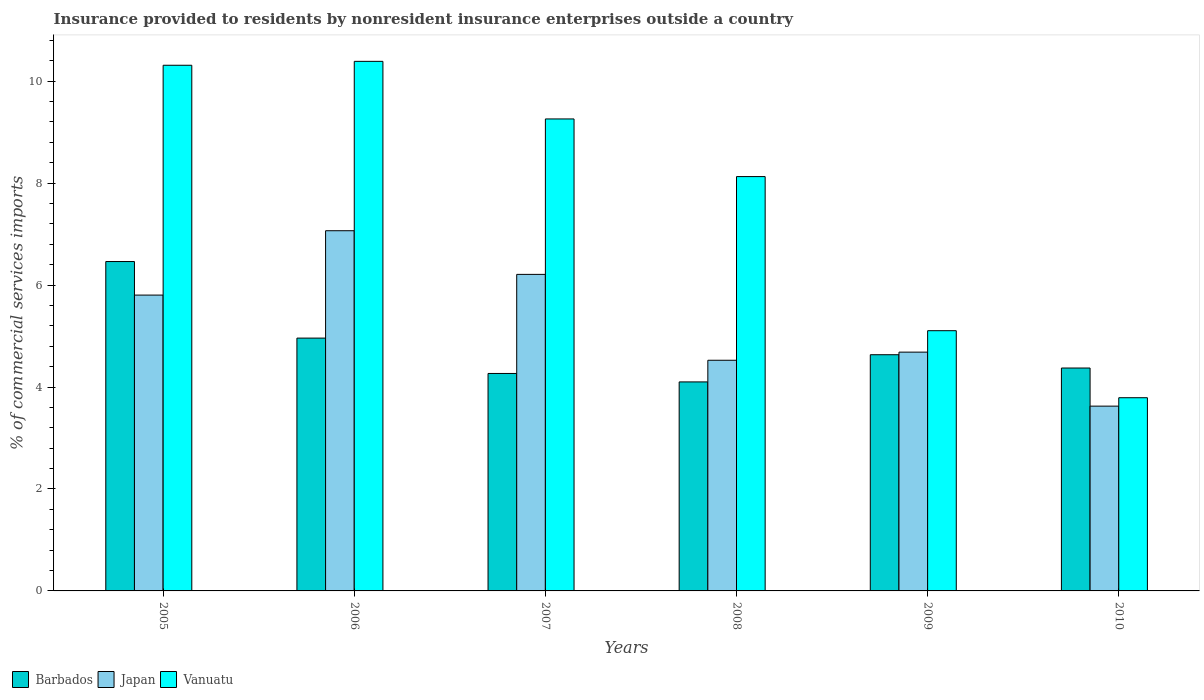How many different coloured bars are there?
Give a very brief answer. 3. How many groups of bars are there?
Offer a very short reply. 6. Are the number of bars per tick equal to the number of legend labels?
Your response must be concise. Yes. How many bars are there on the 5th tick from the left?
Your answer should be very brief. 3. How many bars are there on the 6th tick from the right?
Your answer should be very brief. 3. What is the label of the 5th group of bars from the left?
Offer a terse response. 2009. What is the Insurance provided to residents in Vanuatu in 2008?
Provide a succinct answer. 8.13. Across all years, what is the maximum Insurance provided to residents in Vanuatu?
Keep it short and to the point. 10.39. Across all years, what is the minimum Insurance provided to residents in Japan?
Your response must be concise. 3.63. In which year was the Insurance provided to residents in Japan minimum?
Your answer should be very brief. 2010. What is the total Insurance provided to residents in Vanuatu in the graph?
Offer a very short reply. 46.98. What is the difference between the Insurance provided to residents in Barbados in 2006 and that in 2008?
Ensure brevity in your answer.  0.86. What is the difference between the Insurance provided to residents in Vanuatu in 2008 and the Insurance provided to residents in Barbados in 2006?
Provide a short and direct response. 3.17. What is the average Insurance provided to residents in Vanuatu per year?
Offer a very short reply. 7.83. In the year 2006, what is the difference between the Insurance provided to residents in Japan and Insurance provided to residents in Vanuatu?
Provide a short and direct response. -3.32. What is the ratio of the Insurance provided to residents in Vanuatu in 2007 to that in 2008?
Your answer should be very brief. 1.14. Is the Insurance provided to residents in Vanuatu in 2009 less than that in 2010?
Make the answer very short. No. Is the difference between the Insurance provided to residents in Japan in 2008 and 2010 greater than the difference between the Insurance provided to residents in Vanuatu in 2008 and 2010?
Give a very brief answer. No. What is the difference between the highest and the second highest Insurance provided to residents in Barbados?
Give a very brief answer. 1.5. What is the difference between the highest and the lowest Insurance provided to residents in Barbados?
Offer a terse response. 2.36. In how many years, is the Insurance provided to residents in Barbados greater than the average Insurance provided to residents in Barbados taken over all years?
Offer a very short reply. 2. What does the 1st bar from the left in 2010 represents?
Keep it short and to the point. Barbados. How many bars are there?
Your answer should be compact. 18. Are all the bars in the graph horizontal?
Offer a very short reply. No. What is the difference between two consecutive major ticks on the Y-axis?
Offer a very short reply. 2. Does the graph contain any zero values?
Your response must be concise. No. Does the graph contain grids?
Give a very brief answer. No. Where does the legend appear in the graph?
Your response must be concise. Bottom left. How are the legend labels stacked?
Provide a short and direct response. Horizontal. What is the title of the graph?
Give a very brief answer. Insurance provided to residents by nonresident insurance enterprises outside a country. Does "Qatar" appear as one of the legend labels in the graph?
Ensure brevity in your answer.  No. What is the label or title of the X-axis?
Provide a succinct answer. Years. What is the label or title of the Y-axis?
Your response must be concise. % of commercial services imports. What is the % of commercial services imports of Barbados in 2005?
Give a very brief answer. 6.46. What is the % of commercial services imports in Japan in 2005?
Your response must be concise. 5.8. What is the % of commercial services imports of Vanuatu in 2005?
Keep it short and to the point. 10.31. What is the % of commercial services imports in Barbados in 2006?
Offer a terse response. 4.96. What is the % of commercial services imports in Japan in 2006?
Give a very brief answer. 7.07. What is the % of commercial services imports of Vanuatu in 2006?
Ensure brevity in your answer.  10.39. What is the % of commercial services imports of Barbados in 2007?
Keep it short and to the point. 4.27. What is the % of commercial services imports of Japan in 2007?
Your answer should be compact. 6.21. What is the % of commercial services imports of Vanuatu in 2007?
Your response must be concise. 9.26. What is the % of commercial services imports of Barbados in 2008?
Offer a very short reply. 4.1. What is the % of commercial services imports in Japan in 2008?
Ensure brevity in your answer.  4.53. What is the % of commercial services imports in Vanuatu in 2008?
Your answer should be compact. 8.13. What is the % of commercial services imports in Barbados in 2009?
Your answer should be very brief. 4.63. What is the % of commercial services imports of Japan in 2009?
Keep it short and to the point. 4.68. What is the % of commercial services imports of Vanuatu in 2009?
Your answer should be very brief. 5.1. What is the % of commercial services imports of Barbados in 2010?
Give a very brief answer. 4.37. What is the % of commercial services imports in Japan in 2010?
Your response must be concise. 3.63. What is the % of commercial services imports in Vanuatu in 2010?
Keep it short and to the point. 3.79. Across all years, what is the maximum % of commercial services imports in Barbados?
Your answer should be compact. 6.46. Across all years, what is the maximum % of commercial services imports of Japan?
Make the answer very short. 7.07. Across all years, what is the maximum % of commercial services imports of Vanuatu?
Provide a short and direct response. 10.39. Across all years, what is the minimum % of commercial services imports of Barbados?
Ensure brevity in your answer.  4.1. Across all years, what is the minimum % of commercial services imports of Japan?
Your response must be concise. 3.63. Across all years, what is the minimum % of commercial services imports of Vanuatu?
Provide a succinct answer. 3.79. What is the total % of commercial services imports of Barbados in the graph?
Your answer should be compact. 28.79. What is the total % of commercial services imports of Japan in the graph?
Make the answer very short. 31.91. What is the total % of commercial services imports in Vanuatu in the graph?
Offer a very short reply. 46.98. What is the difference between the % of commercial services imports of Barbados in 2005 and that in 2006?
Your answer should be compact. 1.5. What is the difference between the % of commercial services imports of Japan in 2005 and that in 2006?
Your answer should be very brief. -1.26. What is the difference between the % of commercial services imports of Vanuatu in 2005 and that in 2006?
Offer a terse response. -0.08. What is the difference between the % of commercial services imports in Barbados in 2005 and that in 2007?
Your answer should be very brief. 2.2. What is the difference between the % of commercial services imports in Japan in 2005 and that in 2007?
Offer a terse response. -0.41. What is the difference between the % of commercial services imports in Vanuatu in 2005 and that in 2007?
Your response must be concise. 1.05. What is the difference between the % of commercial services imports of Barbados in 2005 and that in 2008?
Your response must be concise. 2.36. What is the difference between the % of commercial services imports of Japan in 2005 and that in 2008?
Ensure brevity in your answer.  1.28. What is the difference between the % of commercial services imports in Vanuatu in 2005 and that in 2008?
Keep it short and to the point. 2.18. What is the difference between the % of commercial services imports in Barbados in 2005 and that in 2009?
Your answer should be compact. 1.83. What is the difference between the % of commercial services imports of Japan in 2005 and that in 2009?
Offer a terse response. 1.12. What is the difference between the % of commercial services imports of Vanuatu in 2005 and that in 2009?
Your answer should be compact. 5.21. What is the difference between the % of commercial services imports of Barbados in 2005 and that in 2010?
Give a very brief answer. 2.09. What is the difference between the % of commercial services imports of Japan in 2005 and that in 2010?
Offer a terse response. 2.18. What is the difference between the % of commercial services imports in Vanuatu in 2005 and that in 2010?
Provide a succinct answer. 6.52. What is the difference between the % of commercial services imports of Barbados in 2006 and that in 2007?
Your answer should be very brief. 0.69. What is the difference between the % of commercial services imports in Japan in 2006 and that in 2007?
Offer a very short reply. 0.86. What is the difference between the % of commercial services imports of Vanuatu in 2006 and that in 2007?
Provide a short and direct response. 1.13. What is the difference between the % of commercial services imports in Barbados in 2006 and that in 2008?
Keep it short and to the point. 0.86. What is the difference between the % of commercial services imports of Japan in 2006 and that in 2008?
Provide a succinct answer. 2.54. What is the difference between the % of commercial services imports in Vanuatu in 2006 and that in 2008?
Make the answer very short. 2.26. What is the difference between the % of commercial services imports of Barbados in 2006 and that in 2009?
Provide a short and direct response. 0.33. What is the difference between the % of commercial services imports of Japan in 2006 and that in 2009?
Your response must be concise. 2.38. What is the difference between the % of commercial services imports in Vanuatu in 2006 and that in 2009?
Your answer should be compact. 5.28. What is the difference between the % of commercial services imports of Barbados in 2006 and that in 2010?
Ensure brevity in your answer.  0.59. What is the difference between the % of commercial services imports of Japan in 2006 and that in 2010?
Your answer should be compact. 3.44. What is the difference between the % of commercial services imports in Vanuatu in 2006 and that in 2010?
Ensure brevity in your answer.  6.6. What is the difference between the % of commercial services imports of Barbados in 2007 and that in 2008?
Provide a short and direct response. 0.17. What is the difference between the % of commercial services imports of Japan in 2007 and that in 2008?
Provide a succinct answer. 1.68. What is the difference between the % of commercial services imports of Vanuatu in 2007 and that in 2008?
Your answer should be very brief. 1.13. What is the difference between the % of commercial services imports of Barbados in 2007 and that in 2009?
Provide a short and direct response. -0.37. What is the difference between the % of commercial services imports of Japan in 2007 and that in 2009?
Your response must be concise. 1.53. What is the difference between the % of commercial services imports in Vanuatu in 2007 and that in 2009?
Your response must be concise. 4.15. What is the difference between the % of commercial services imports in Barbados in 2007 and that in 2010?
Your answer should be compact. -0.11. What is the difference between the % of commercial services imports of Japan in 2007 and that in 2010?
Keep it short and to the point. 2.58. What is the difference between the % of commercial services imports of Vanuatu in 2007 and that in 2010?
Give a very brief answer. 5.47. What is the difference between the % of commercial services imports in Barbados in 2008 and that in 2009?
Your response must be concise. -0.53. What is the difference between the % of commercial services imports of Japan in 2008 and that in 2009?
Ensure brevity in your answer.  -0.16. What is the difference between the % of commercial services imports in Vanuatu in 2008 and that in 2009?
Your answer should be compact. 3.02. What is the difference between the % of commercial services imports of Barbados in 2008 and that in 2010?
Provide a short and direct response. -0.27. What is the difference between the % of commercial services imports in Japan in 2008 and that in 2010?
Make the answer very short. 0.9. What is the difference between the % of commercial services imports in Vanuatu in 2008 and that in 2010?
Offer a terse response. 4.34. What is the difference between the % of commercial services imports of Barbados in 2009 and that in 2010?
Provide a succinct answer. 0.26. What is the difference between the % of commercial services imports in Japan in 2009 and that in 2010?
Provide a short and direct response. 1.06. What is the difference between the % of commercial services imports of Vanuatu in 2009 and that in 2010?
Your answer should be very brief. 1.31. What is the difference between the % of commercial services imports of Barbados in 2005 and the % of commercial services imports of Japan in 2006?
Provide a succinct answer. -0.6. What is the difference between the % of commercial services imports in Barbados in 2005 and the % of commercial services imports in Vanuatu in 2006?
Make the answer very short. -3.93. What is the difference between the % of commercial services imports of Japan in 2005 and the % of commercial services imports of Vanuatu in 2006?
Offer a very short reply. -4.59. What is the difference between the % of commercial services imports in Barbados in 2005 and the % of commercial services imports in Japan in 2007?
Your answer should be very brief. 0.25. What is the difference between the % of commercial services imports in Barbados in 2005 and the % of commercial services imports in Vanuatu in 2007?
Give a very brief answer. -2.8. What is the difference between the % of commercial services imports in Japan in 2005 and the % of commercial services imports in Vanuatu in 2007?
Offer a very short reply. -3.46. What is the difference between the % of commercial services imports of Barbados in 2005 and the % of commercial services imports of Japan in 2008?
Your answer should be compact. 1.94. What is the difference between the % of commercial services imports of Barbados in 2005 and the % of commercial services imports of Vanuatu in 2008?
Your answer should be compact. -1.67. What is the difference between the % of commercial services imports of Japan in 2005 and the % of commercial services imports of Vanuatu in 2008?
Offer a very short reply. -2.32. What is the difference between the % of commercial services imports of Barbados in 2005 and the % of commercial services imports of Japan in 2009?
Provide a short and direct response. 1.78. What is the difference between the % of commercial services imports in Barbados in 2005 and the % of commercial services imports in Vanuatu in 2009?
Keep it short and to the point. 1.36. What is the difference between the % of commercial services imports of Japan in 2005 and the % of commercial services imports of Vanuatu in 2009?
Your answer should be compact. 0.7. What is the difference between the % of commercial services imports of Barbados in 2005 and the % of commercial services imports of Japan in 2010?
Ensure brevity in your answer.  2.84. What is the difference between the % of commercial services imports of Barbados in 2005 and the % of commercial services imports of Vanuatu in 2010?
Offer a very short reply. 2.67. What is the difference between the % of commercial services imports of Japan in 2005 and the % of commercial services imports of Vanuatu in 2010?
Provide a short and direct response. 2.01. What is the difference between the % of commercial services imports of Barbados in 2006 and the % of commercial services imports of Japan in 2007?
Provide a succinct answer. -1.25. What is the difference between the % of commercial services imports of Barbados in 2006 and the % of commercial services imports of Vanuatu in 2007?
Give a very brief answer. -4.3. What is the difference between the % of commercial services imports in Japan in 2006 and the % of commercial services imports in Vanuatu in 2007?
Give a very brief answer. -2.19. What is the difference between the % of commercial services imports in Barbados in 2006 and the % of commercial services imports in Japan in 2008?
Ensure brevity in your answer.  0.43. What is the difference between the % of commercial services imports in Barbados in 2006 and the % of commercial services imports in Vanuatu in 2008?
Ensure brevity in your answer.  -3.17. What is the difference between the % of commercial services imports of Japan in 2006 and the % of commercial services imports of Vanuatu in 2008?
Keep it short and to the point. -1.06. What is the difference between the % of commercial services imports in Barbados in 2006 and the % of commercial services imports in Japan in 2009?
Offer a terse response. 0.28. What is the difference between the % of commercial services imports in Barbados in 2006 and the % of commercial services imports in Vanuatu in 2009?
Offer a very short reply. -0.15. What is the difference between the % of commercial services imports of Japan in 2006 and the % of commercial services imports of Vanuatu in 2009?
Offer a terse response. 1.96. What is the difference between the % of commercial services imports in Barbados in 2006 and the % of commercial services imports in Japan in 2010?
Make the answer very short. 1.33. What is the difference between the % of commercial services imports of Barbados in 2006 and the % of commercial services imports of Vanuatu in 2010?
Your answer should be very brief. 1.17. What is the difference between the % of commercial services imports of Japan in 2006 and the % of commercial services imports of Vanuatu in 2010?
Your answer should be very brief. 3.28. What is the difference between the % of commercial services imports of Barbados in 2007 and the % of commercial services imports of Japan in 2008?
Keep it short and to the point. -0.26. What is the difference between the % of commercial services imports in Barbados in 2007 and the % of commercial services imports in Vanuatu in 2008?
Your answer should be very brief. -3.86. What is the difference between the % of commercial services imports of Japan in 2007 and the % of commercial services imports of Vanuatu in 2008?
Provide a succinct answer. -1.92. What is the difference between the % of commercial services imports of Barbados in 2007 and the % of commercial services imports of Japan in 2009?
Your answer should be very brief. -0.42. What is the difference between the % of commercial services imports in Barbados in 2007 and the % of commercial services imports in Vanuatu in 2009?
Provide a succinct answer. -0.84. What is the difference between the % of commercial services imports of Japan in 2007 and the % of commercial services imports of Vanuatu in 2009?
Keep it short and to the point. 1.1. What is the difference between the % of commercial services imports of Barbados in 2007 and the % of commercial services imports of Japan in 2010?
Provide a succinct answer. 0.64. What is the difference between the % of commercial services imports in Barbados in 2007 and the % of commercial services imports in Vanuatu in 2010?
Ensure brevity in your answer.  0.48. What is the difference between the % of commercial services imports in Japan in 2007 and the % of commercial services imports in Vanuatu in 2010?
Offer a very short reply. 2.42. What is the difference between the % of commercial services imports in Barbados in 2008 and the % of commercial services imports in Japan in 2009?
Your answer should be compact. -0.58. What is the difference between the % of commercial services imports of Barbados in 2008 and the % of commercial services imports of Vanuatu in 2009?
Make the answer very short. -1. What is the difference between the % of commercial services imports of Japan in 2008 and the % of commercial services imports of Vanuatu in 2009?
Offer a very short reply. -0.58. What is the difference between the % of commercial services imports in Barbados in 2008 and the % of commercial services imports in Japan in 2010?
Offer a terse response. 0.48. What is the difference between the % of commercial services imports in Barbados in 2008 and the % of commercial services imports in Vanuatu in 2010?
Offer a terse response. 0.31. What is the difference between the % of commercial services imports in Japan in 2008 and the % of commercial services imports in Vanuatu in 2010?
Your answer should be compact. 0.73. What is the difference between the % of commercial services imports in Barbados in 2009 and the % of commercial services imports in Japan in 2010?
Offer a very short reply. 1.01. What is the difference between the % of commercial services imports of Barbados in 2009 and the % of commercial services imports of Vanuatu in 2010?
Offer a terse response. 0.84. What is the difference between the % of commercial services imports in Japan in 2009 and the % of commercial services imports in Vanuatu in 2010?
Keep it short and to the point. 0.89. What is the average % of commercial services imports of Barbados per year?
Keep it short and to the point. 4.8. What is the average % of commercial services imports in Japan per year?
Your answer should be compact. 5.32. What is the average % of commercial services imports of Vanuatu per year?
Keep it short and to the point. 7.83. In the year 2005, what is the difference between the % of commercial services imports in Barbados and % of commercial services imports in Japan?
Keep it short and to the point. 0.66. In the year 2005, what is the difference between the % of commercial services imports of Barbados and % of commercial services imports of Vanuatu?
Offer a terse response. -3.85. In the year 2005, what is the difference between the % of commercial services imports of Japan and % of commercial services imports of Vanuatu?
Make the answer very short. -4.51. In the year 2006, what is the difference between the % of commercial services imports in Barbados and % of commercial services imports in Japan?
Your response must be concise. -2.11. In the year 2006, what is the difference between the % of commercial services imports of Barbados and % of commercial services imports of Vanuatu?
Your answer should be very brief. -5.43. In the year 2006, what is the difference between the % of commercial services imports of Japan and % of commercial services imports of Vanuatu?
Provide a succinct answer. -3.32. In the year 2007, what is the difference between the % of commercial services imports of Barbados and % of commercial services imports of Japan?
Ensure brevity in your answer.  -1.94. In the year 2007, what is the difference between the % of commercial services imports in Barbados and % of commercial services imports in Vanuatu?
Offer a terse response. -4.99. In the year 2007, what is the difference between the % of commercial services imports of Japan and % of commercial services imports of Vanuatu?
Offer a very short reply. -3.05. In the year 2008, what is the difference between the % of commercial services imports of Barbados and % of commercial services imports of Japan?
Ensure brevity in your answer.  -0.42. In the year 2008, what is the difference between the % of commercial services imports of Barbados and % of commercial services imports of Vanuatu?
Offer a very short reply. -4.03. In the year 2008, what is the difference between the % of commercial services imports in Japan and % of commercial services imports in Vanuatu?
Keep it short and to the point. -3.6. In the year 2009, what is the difference between the % of commercial services imports in Barbados and % of commercial services imports in Japan?
Offer a terse response. -0.05. In the year 2009, what is the difference between the % of commercial services imports of Barbados and % of commercial services imports of Vanuatu?
Make the answer very short. -0.47. In the year 2009, what is the difference between the % of commercial services imports in Japan and % of commercial services imports in Vanuatu?
Your answer should be compact. -0.42. In the year 2010, what is the difference between the % of commercial services imports in Barbados and % of commercial services imports in Japan?
Offer a terse response. 0.75. In the year 2010, what is the difference between the % of commercial services imports of Barbados and % of commercial services imports of Vanuatu?
Give a very brief answer. 0.58. In the year 2010, what is the difference between the % of commercial services imports of Japan and % of commercial services imports of Vanuatu?
Keep it short and to the point. -0.17. What is the ratio of the % of commercial services imports in Barbados in 2005 to that in 2006?
Keep it short and to the point. 1.3. What is the ratio of the % of commercial services imports of Japan in 2005 to that in 2006?
Keep it short and to the point. 0.82. What is the ratio of the % of commercial services imports of Vanuatu in 2005 to that in 2006?
Provide a succinct answer. 0.99. What is the ratio of the % of commercial services imports of Barbados in 2005 to that in 2007?
Provide a short and direct response. 1.51. What is the ratio of the % of commercial services imports in Japan in 2005 to that in 2007?
Provide a short and direct response. 0.93. What is the ratio of the % of commercial services imports in Vanuatu in 2005 to that in 2007?
Your answer should be compact. 1.11. What is the ratio of the % of commercial services imports in Barbados in 2005 to that in 2008?
Offer a very short reply. 1.58. What is the ratio of the % of commercial services imports in Japan in 2005 to that in 2008?
Your response must be concise. 1.28. What is the ratio of the % of commercial services imports of Vanuatu in 2005 to that in 2008?
Offer a terse response. 1.27. What is the ratio of the % of commercial services imports in Barbados in 2005 to that in 2009?
Offer a very short reply. 1.39. What is the ratio of the % of commercial services imports in Japan in 2005 to that in 2009?
Provide a short and direct response. 1.24. What is the ratio of the % of commercial services imports in Vanuatu in 2005 to that in 2009?
Provide a short and direct response. 2.02. What is the ratio of the % of commercial services imports in Barbados in 2005 to that in 2010?
Keep it short and to the point. 1.48. What is the ratio of the % of commercial services imports of Japan in 2005 to that in 2010?
Give a very brief answer. 1.6. What is the ratio of the % of commercial services imports in Vanuatu in 2005 to that in 2010?
Your answer should be very brief. 2.72. What is the ratio of the % of commercial services imports of Barbados in 2006 to that in 2007?
Give a very brief answer. 1.16. What is the ratio of the % of commercial services imports of Japan in 2006 to that in 2007?
Your answer should be very brief. 1.14. What is the ratio of the % of commercial services imports in Vanuatu in 2006 to that in 2007?
Offer a terse response. 1.12. What is the ratio of the % of commercial services imports of Barbados in 2006 to that in 2008?
Offer a terse response. 1.21. What is the ratio of the % of commercial services imports in Japan in 2006 to that in 2008?
Ensure brevity in your answer.  1.56. What is the ratio of the % of commercial services imports of Vanuatu in 2006 to that in 2008?
Provide a succinct answer. 1.28. What is the ratio of the % of commercial services imports of Barbados in 2006 to that in 2009?
Your response must be concise. 1.07. What is the ratio of the % of commercial services imports of Japan in 2006 to that in 2009?
Give a very brief answer. 1.51. What is the ratio of the % of commercial services imports of Vanuatu in 2006 to that in 2009?
Your answer should be very brief. 2.04. What is the ratio of the % of commercial services imports in Barbados in 2006 to that in 2010?
Your answer should be compact. 1.13. What is the ratio of the % of commercial services imports of Japan in 2006 to that in 2010?
Give a very brief answer. 1.95. What is the ratio of the % of commercial services imports of Vanuatu in 2006 to that in 2010?
Your response must be concise. 2.74. What is the ratio of the % of commercial services imports in Barbados in 2007 to that in 2008?
Make the answer very short. 1.04. What is the ratio of the % of commercial services imports in Japan in 2007 to that in 2008?
Your answer should be very brief. 1.37. What is the ratio of the % of commercial services imports of Vanuatu in 2007 to that in 2008?
Offer a terse response. 1.14. What is the ratio of the % of commercial services imports in Barbados in 2007 to that in 2009?
Your answer should be compact. 0.92. What is the ratio of the % of commercial services imports in Japan in 2007 to that in 2009?
Provide a succinct answer. 1.33. What is the ratio of the % of commercial services imports in Vanuatu in 2007 to that in 2009?
Your answer should be very brief. 1.81. What is the ratio of the % of commercial services imports of Barbados in 2007 to that in 2010?
Provide a succinct answer. 0.98. What is the ratio of the % of commercial services imports of Japan in 2007 to that in 2010?
Provide a succinct answer. 1.71. What is the ratio of the % of commercial services imports in Vanuatu in 2007 to that in 2010?
Your response must be concise. 2.44. What is the ratio of the % of commercial services imports in Barbados in 2008 to that in 2009?
Make the answer very short. 0.88. What is the ratio of the % of commercial services imports of Japan in 2008 to that in 2009?
Ensure brevity in your answer.  0.97. What is the ratio of the % of commercial services imports in Vanuatu in 2008 to that in 2009?
Keep it short and to the point. 1.59. What is the ratio of the % of commercial services imports in Barbados in 2008 to that in 2010?
Provide a short and direct response. 0.94. What is the ratio of the % of commercial services imports in Japan in 2008 to that in 2010?
Your answer should be very brief. 1.25. What is the ratio of the % of commercial services imports of Vanuatu in 2008 to that in 2010?
Provide a short and direct response. 2.14. What is the ratio of the % of commercial services imports in Barbados in 2009 to that in 2010?
Provide a short and direct response. 1.06. What is the ratio of the % of commercial services imports in Japan in 2009 to that in 2010?
Offer a very short reply. 1.29. What is the ratio of the % of commercial services imports in Vanuatu in 2009 to that in 2010?
Ensure brevity in your answer.  1.35. What is the difference between the highest and the second highest % of commercial services imports in Barbados?
Your answer should be compact. 1.5. What is the difference between the highest and the second highest % of commercial services imports of Japan?
Your answer should be very brief. 0.86. What is the difference between the highest and the second highest % of commercial services imports in Vanuatu?
Offer a very short reply. 0.08. What is the difference between the highest and the lowest % of commercial services imports in Barbados?
Ensure brevity in your answer.  2.36. What is the difference between the highest and the lowest % of commercial services imports of Japan?
Give a very brief answer. 3.44. What is the difference between the highest and the lowest % of commercial services imports of Vanuatu?
Keep it short and to the point. 6.6. 